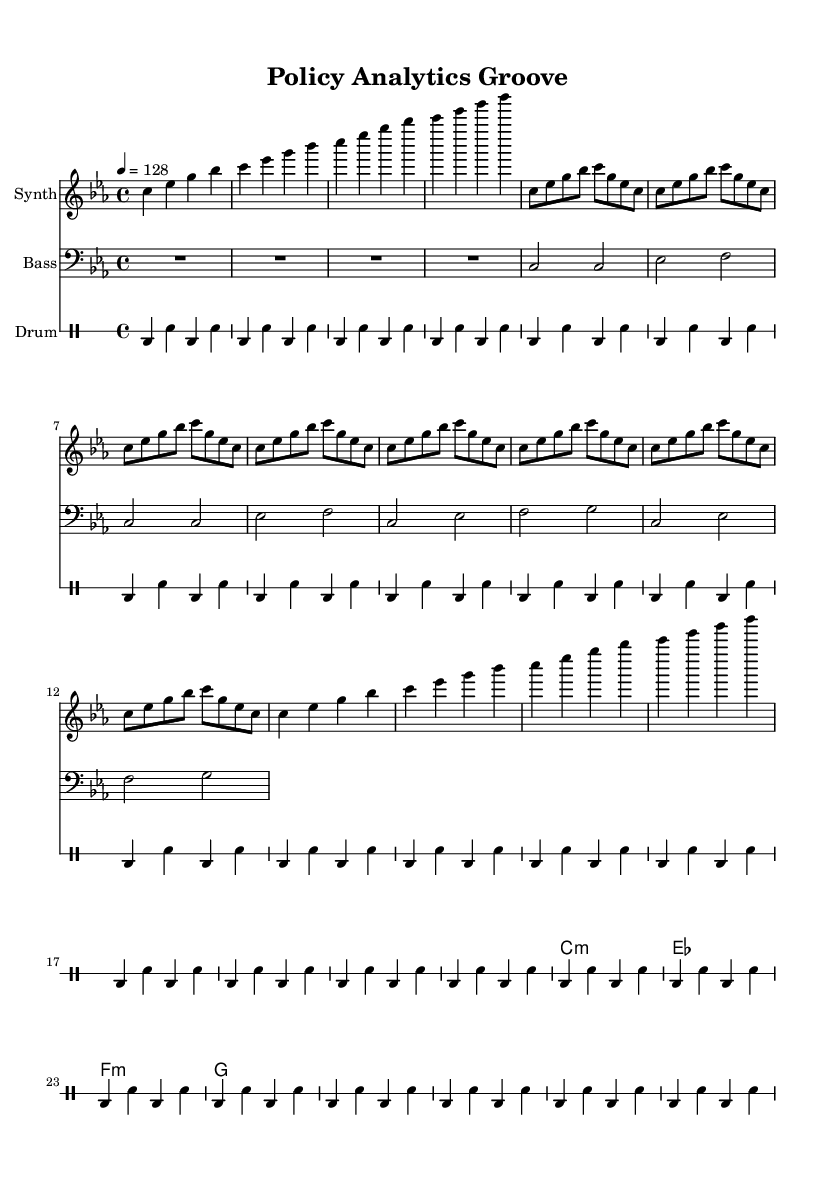What is the key signature of this music? The key signature indicated in the global section shows two flats (B, E) which signifies a minor key. In this context, it is C minor.
Answer: C minor What is the time signature of this music? The time signature is mentioned directly in the global section and is written as 4/4, indicating there are 4 beats in a measure.
Answer: 4/4 What is the tempo marking for this piece? The tempo marking specified in the global section shows that the piece should be played at a quarter note value of 128 beats per minute.
Answer: 128 How many measures are in the synth verse? The synth verse is structured with a repeated section, and by counting the repeating units, there are a total of 8 measures (2 repeats of 4 measures each).
Answer: 8 Which instruments are used in this composition? The sheet music indicates the presence of three distinct parts: Synth, Bass, and Drum, each denoted at the heads of their respective staves.
Answer: Synth, Bass, Drum How many times does the bass play the notes in the bass verse section? The bass verse section consists of 4 measures. Since the bass is played for 2 counts in each measure and repeated across the section, it plays 4 times throughout.
Answer: 4 What rhythmic pattern is the drum following? The drum part shows a repetitive pattern of 4 beats consisting of bass drum (bd) and snare drum (sn) in a specified sequence, repeated 28 times.
Answer: Bass-sn 